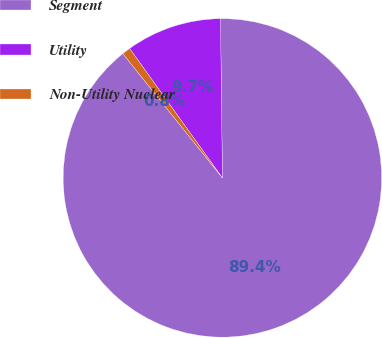Convert chart to OTSL. <chart><loc_0><loc_0><loc_500><loc_500><pie_chart><fcel>Segment<fcel>Utility<fcel>Non-Utility Nuclear<nl><fcel>89.45%<fcel>9.71%<fcel>0.85%<nl></chart> 